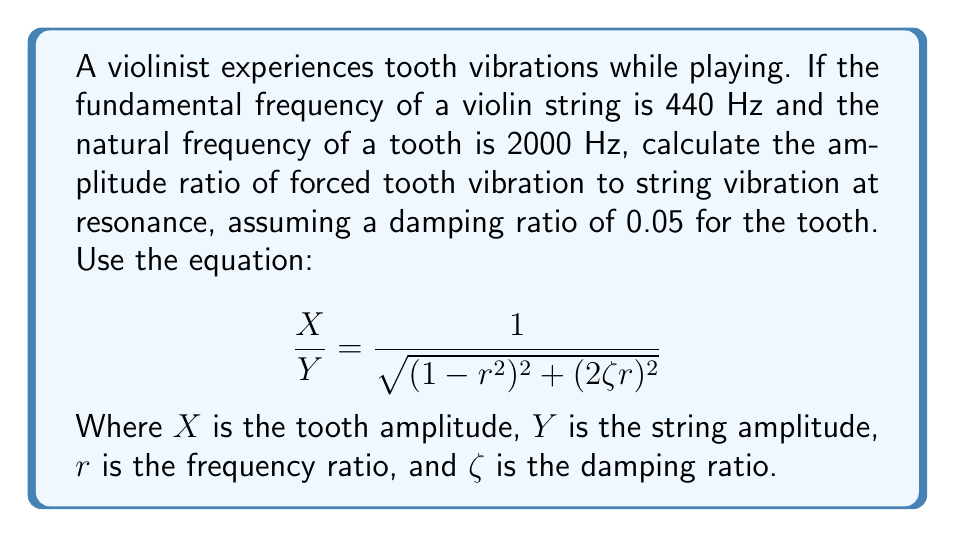Solve this math problem. To solve this problem, we'll follow these steps:

1) First, calculate the frequency ratio $r$:
   $r = \frac{\text{forcing frequency}}{\text{natural frequency}} = \frac{440 \text{ Hz}}{2000 \text{ Hz}} = 0.22$

2) We're given the damping ratio $\zeta = 0.05$

3) Now, let's substitute these values into the equation:

   $$\frac{X}{Y} = \frac{1}{\sqrt{(1-r^2)^2 + (2\zeta r)^2}}$$

   $$\frac{X}{Y} = \frac{1}{\sqrt{(1-0.22^2)^2 + (2 \cdot 0.05 \cdot 0.22)^2}}$$

4) Let's calculate the parts inside the square root:
   $(1-0.22^2)^2 = (1-0.0484)^2 = 0.9516^2 = 0.9055$
   $(2 \cdot 0.05 \cdot 0.22)^2 = 0.022^2 = 0.000484$

5) Add these parts:
   $0.9055 + 0.000484 = 0.905984$

6) Take the square root:
   $\sqrt{0.905984} = 0.9518$

7) Finally, calculate the reciprocal:
   $\frac{1}{0.9518} = 1.0507$

Therefore, the amplitude ratio of forced tooth vibration to string vibration is approximately 1.0507.
Answer: 1.0507 